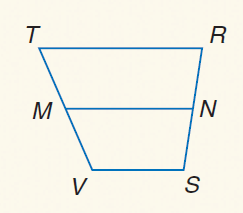Answer the mathemtical geometry problem and directly provide the correct option letter.
Question: For trapezoid T R S V, M and N are midpoints of the legs. If V S = 21 and T R = 44, find M N.
Choices: A: 21 B: 32.5 C: 44 D: 65 B 